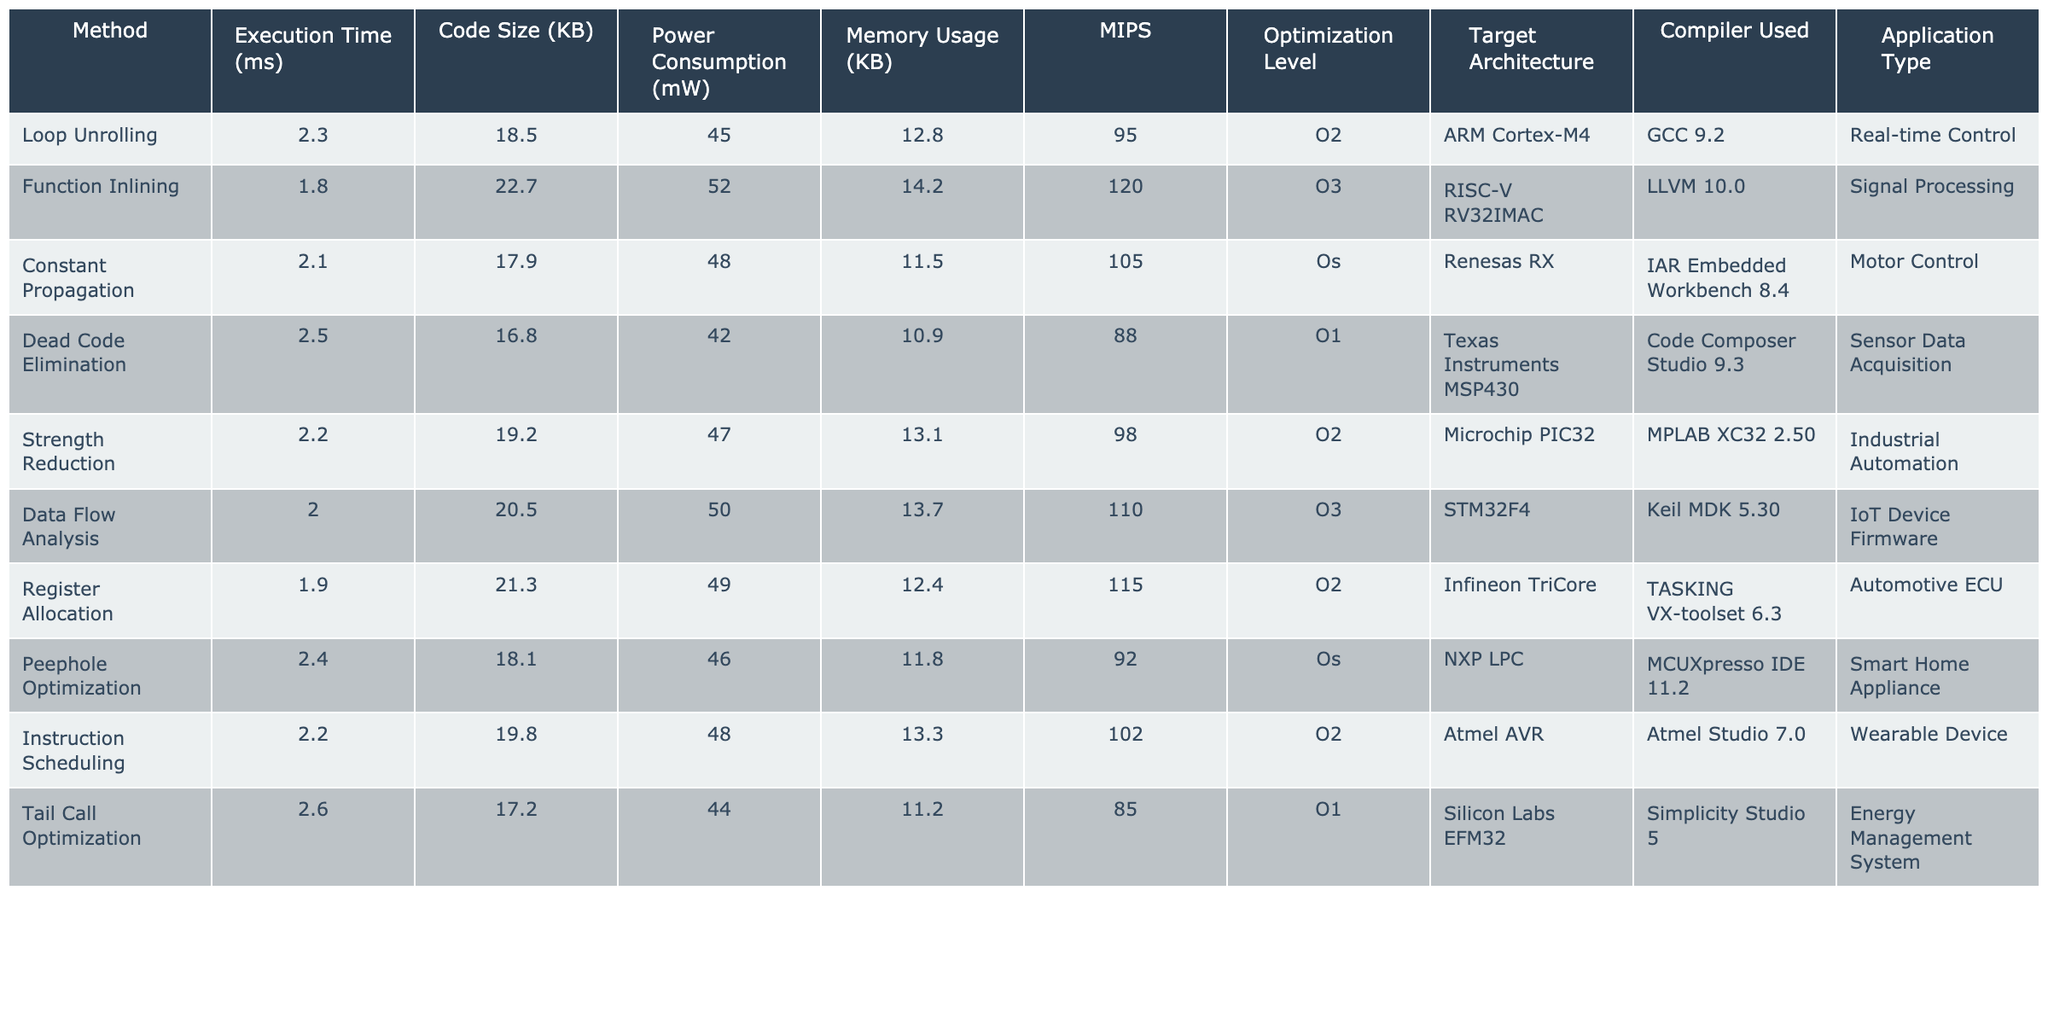What is the execution time of Function Inlining? Referring to the table, the execution time for Function Inlining is directly listed as 1.8 ms.
Answer: 1.8 ms Which method has the highest power consumption? By comparing the Power Consumption column, Function Inlining has the highest power consumption listed at 52 mW.
Answer: Function Inlining What is the average execution time of all methods? The execution times are: 2.3, 1.8, 2.1, 2.5, 2.2, 2.0, 1.9, 2.4, 2.2, and 2.6 ms. Summing these gives 22.0 ms. Dividing by 10 methods yields an average of 2.2 ms.
Answer: 2.2 ms Is the Code Size for Dead Code Elimination higher or lower than for Register Allocation? The Code Size for Dead Code Elimination is 16.8 KB, and for Register Allocation, it is 21.3 KB. Since 16.8 is lower than 21.3, Dead Code Elimination has a lower Code Size.
Answer: Lower What is the difference in Memory Usage between the method with the highest MIPS and the method with the lowest MIPS? The method with the highest MIPS is Function Inlining at 120 MIPS, while the lowest is Tail Call Optimization at 85 MIPS. The difference in MIPS is 120 - 85 = 35. The Memory Usage for Function Inlining is 14.2 KB, and for Tail Call Optimization, it is 11.2 KB. The difference in Memory Usage is 14.2 - 11.2 = 3.0 KB.
Answer: MIPS difference is 35; Memory Usage difference is 3.0 KB Which method has the smallest Code Size and what is it? Scanning the Code Size column, the smallest value is 16.8 KB from the Dead Code Elimination method.
Answer: 16.8 KB Are any methods optimized at level O3? If so, name them. The methods optimized at level O3 are Function Inlining and Data Flow Analysis. Both are listed in the Optimization Level column.
Answer: Yes, Function Inlining and Data Flow Analysis If we group methods by target architecture and look at power consumption, which architecture yields the lowest total power consumption? Summing the power consumption for each architecture: ARM Cortex-M4: 45 mW, RISC-V: 52 mW, Renesas RX: 48 mW, MSP430: 42 mW, and so on. The architecture that yields the lowest total (with architecture having multiple mentioned methods) is Texas Instruments MSP430 with an individual measurement of 42 mW.
Answer: Texas Instruments MSP430 What percentage of the total memory usage does the method with the highest memory usage account for? The highest Memory Usage is 14.2 KB for Function Inlining; the total memory usage is 12.8 + 14.2 + 11.5 + 10.9 + 13.1 + 13.7 + 12.4 + 11.8 + 13.3 + 11.2 = 139.0 KB. The percentage is (14.2 / 139.0) * 100 = 10.19%.
Answer: 10.19% 